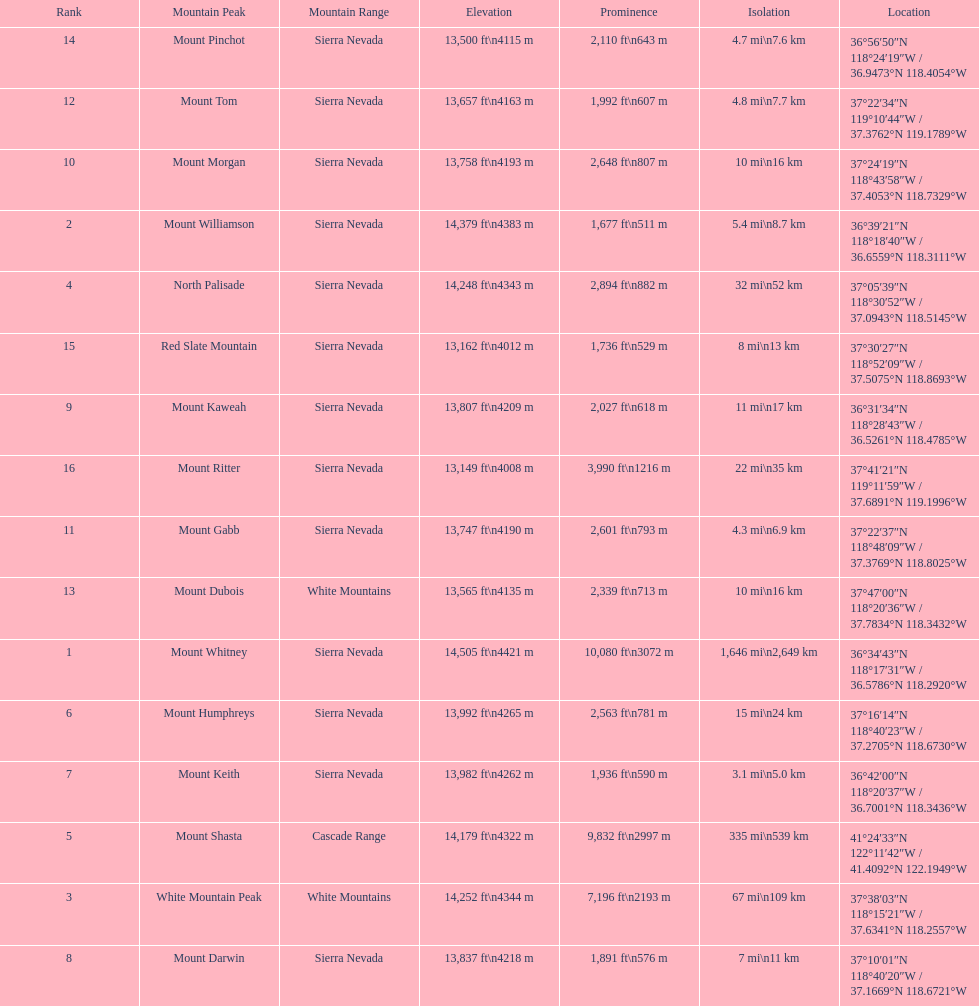What is the only mountain peak listed for the cascade range? Mount Shasta. 